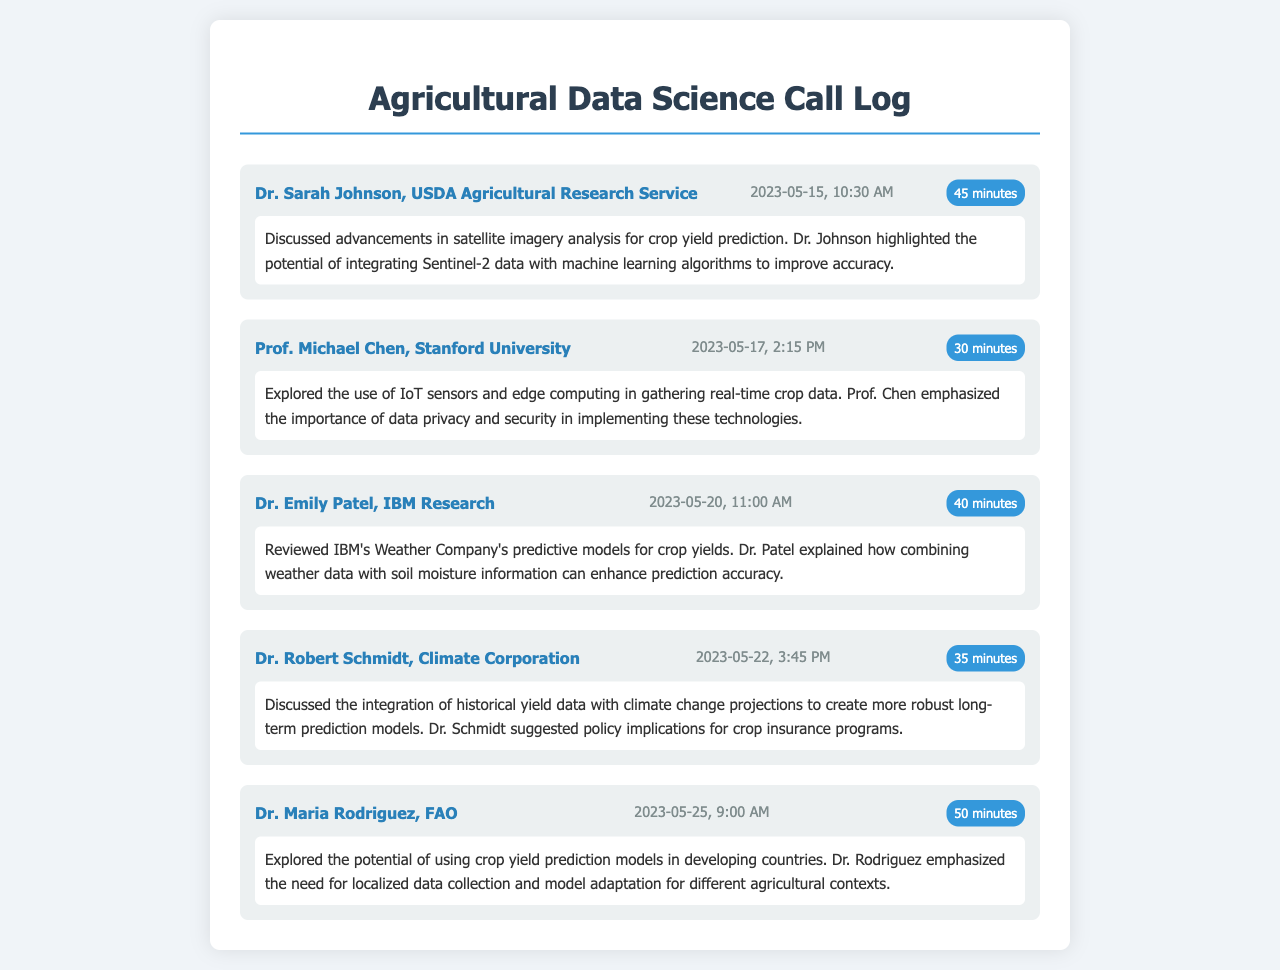what is the name of the first caller? The first caller listed in the document is Dr. Sarah Johnson from the USDA Agricultural Research Service.
Answer: Dr. Sarah Johnson what date was the call with Prof. Michael Chen? The call with Prof. Michael Chen took place on May 17, 2023.
Answer: 2023-05-17 how long was Dr. Emily Patel's call? The duration of Dr. Emily Patel's call is stated to be 40 minutes.
Answer: 40 minutes what crop yield prediction method did Dr. Robert Schmidt discuss? Dr. Robert Schmidt discussed integrating historical yield data with climate change projections.
Answer: integrating historical yield data with climate change projections which organization does Dr. Maria Rodriguez represent? Dr. Maria Rodriguez is from the FAO, which stands for the Food and Agriculture Organization.
Answer: FAO what key technology did Prof. Michael Chen emphasize during his call? Prof. Chen emphasized the importance of data privacy and security in implementing IoT sensors and edge computing.
Answer: data privacy and security which data source did Dr. Sarah Johnson suggest integrating with machine learning? Dr. Johnson suggested integrating Sentinel-2 data with machine learning algorithms.
Answer: Sentinel-2 data what was a significant concern raised by Prof. Michael Chen? Prof. Chen raised concerns about data privacy and security regarding IoT sensor technologies.
Answer: data privacy and security what was the total duration of calls mentioned in the log? To find the total duration, we sum the durations of all calls: 45 + 30 + 40 + 35 + 50 = 200 minutes.
Answer: 200 minutes 